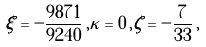<formula> <loc_0><loc_0><loc_500><loc_500>\xi = - \frac { 9 8 7 1 } { 9 2 4 0 } \, , \kappa = 0 \, , \zeta = - \frac { 7 } { 3 3 } \, ,</formula> 